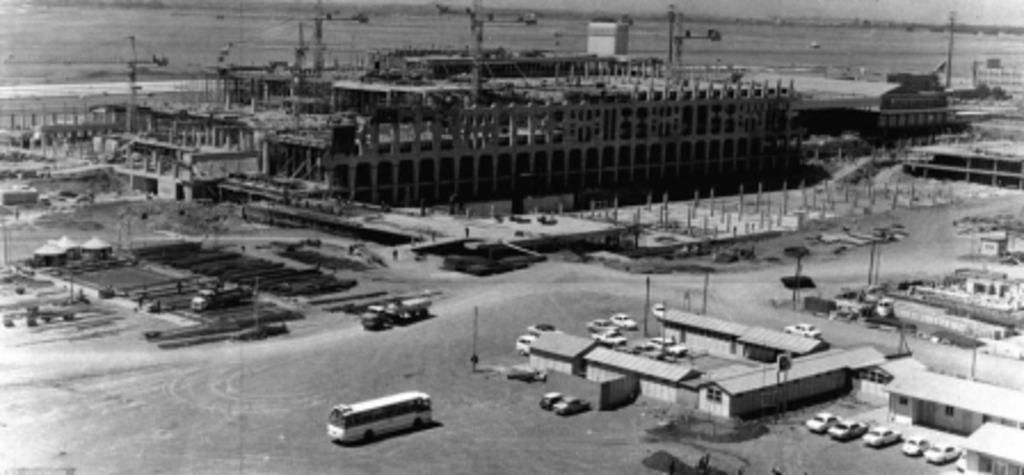In one or two sentences, can you explain what this image depicts? This is a black and white image. In this image we can see many buildings, vehicles and poles. And we can see construction of a building. In the background it is looking blur. 